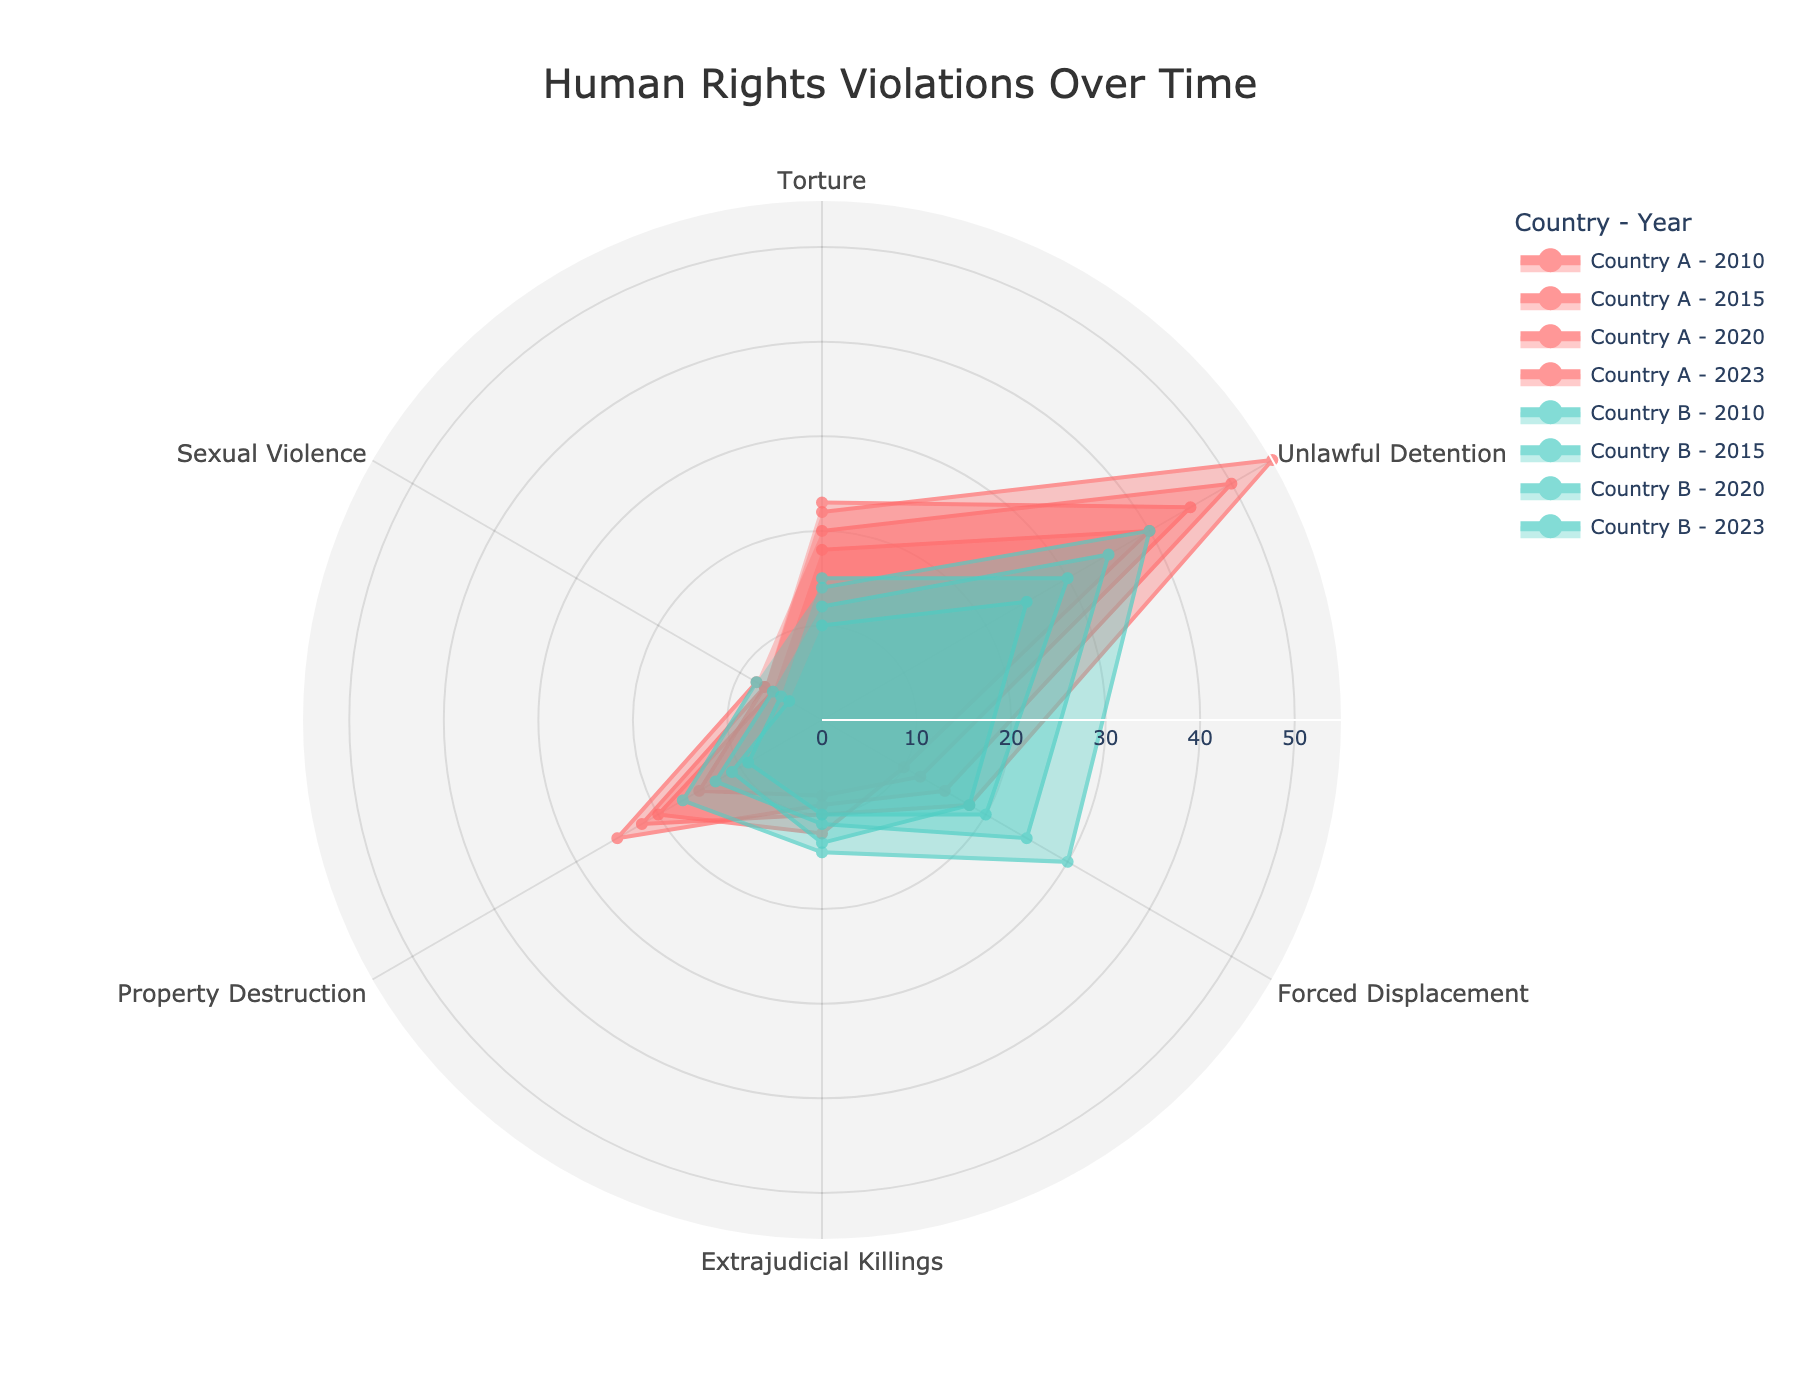What's the title of the figure? The title of the figure is usually placed at the top and is in larger font size. It’s intended to provide a quick understanding of what the figure depicts.
Answer: Human Rights Violations Over Time How many types of human rights abuses are visualized in the figure? The types of human rights abuses are represented as categories around the radar chart. Counting these categories will give the total number of types.
Answer: Six Which country experienced the highest number of unlawful detentions in 2023? The data for each country per year is plotted with a different line. To find the highest number of unlawful detentions, look for the peak in the 'Unlawful Detention' axis for 2023.
Answer: Country A Between 2010 and 2023, how has the trend for torture cases in Country A changed? Look at the values for torture in Country A for the years 2010 and 2023. Check the changes in the plotted points on the radar chart for these years to determine the trend.
Answer: Increased slightly For Country B, which type of abuse saw the largest increase from 2010 to 2023? Compare the values for each type of abuse in Country B from 2010 to 2023. The largest difference indicates the biggest increase.
Answer: Forced Displacement Which year shows the highest instance of property destruction for Country B? Look at the 'Property Destruction' axis for each year’s line corresponding to Country B. Identify the year with the highest value.
Answer: 2023 What is the combined total of forced displacement cases in 2020 for both Country A and Country B? Sum the values of forced displacement for Country A and Country B in the year 2020. The combined total gives the total number of cases.
Answer: 40 Did Country A or Country B report more instances of sexual violence in 2023? Compare the values for sexual violence in 2023 between Country A and Country B. Look at the respective lines in the radar chart.
Answer: Country B Which type of abuse saw a decrease in Country B from 2015 to 2020? Compare the values for each type of abuse in Country B between 2015 and 2020. The type with a reduced value indicates a decrease.
Answer: Unlawful Detention 